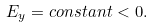Convert formula to latex. <formula><loc_0><loc_0><loc_500><loc_500>E _ { y } = c o n s t a n t < 0 .</formula> 